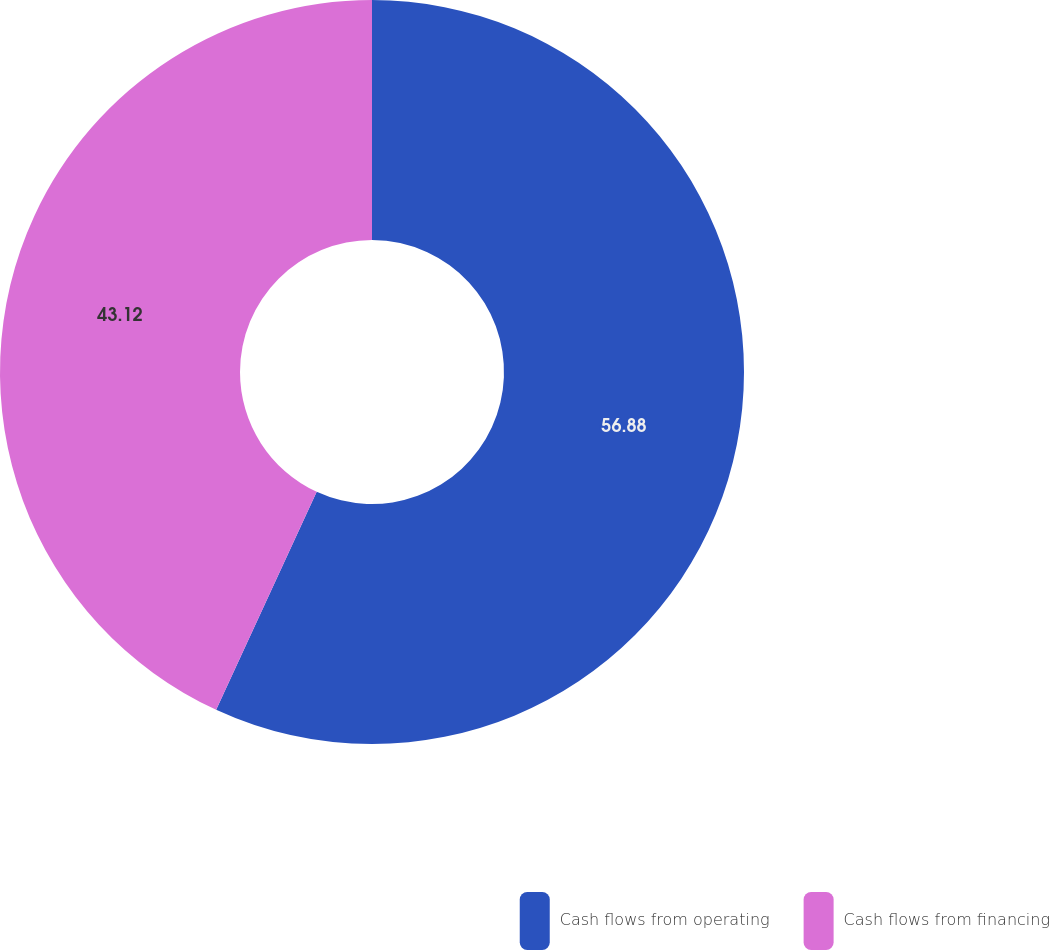Convert chart. <chart><loc_0><loc_0><loc_500><loc_500><pie_chart><fcel>Cash flows from operating<fcel>Cash flows from financing<nl><fcel>56.88%<fcel>43.12%<nl></chart> 